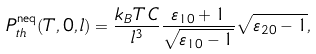<formula> <loc_0><loc_0><loc_500><loc_500>P _ { t h } ^ { \text {neq} } ( T , 0 , l ) = \frac { k _ { B } T \, C } { l ^ { 3 } } \frac { \varepsilon _ { 1 0 } + 1 } { \sqrt { \varepsilon _ { 1 0 } - 1 } } \sqrt { \varepsilon _ { 2 0 } - 1 } ,</formula> 